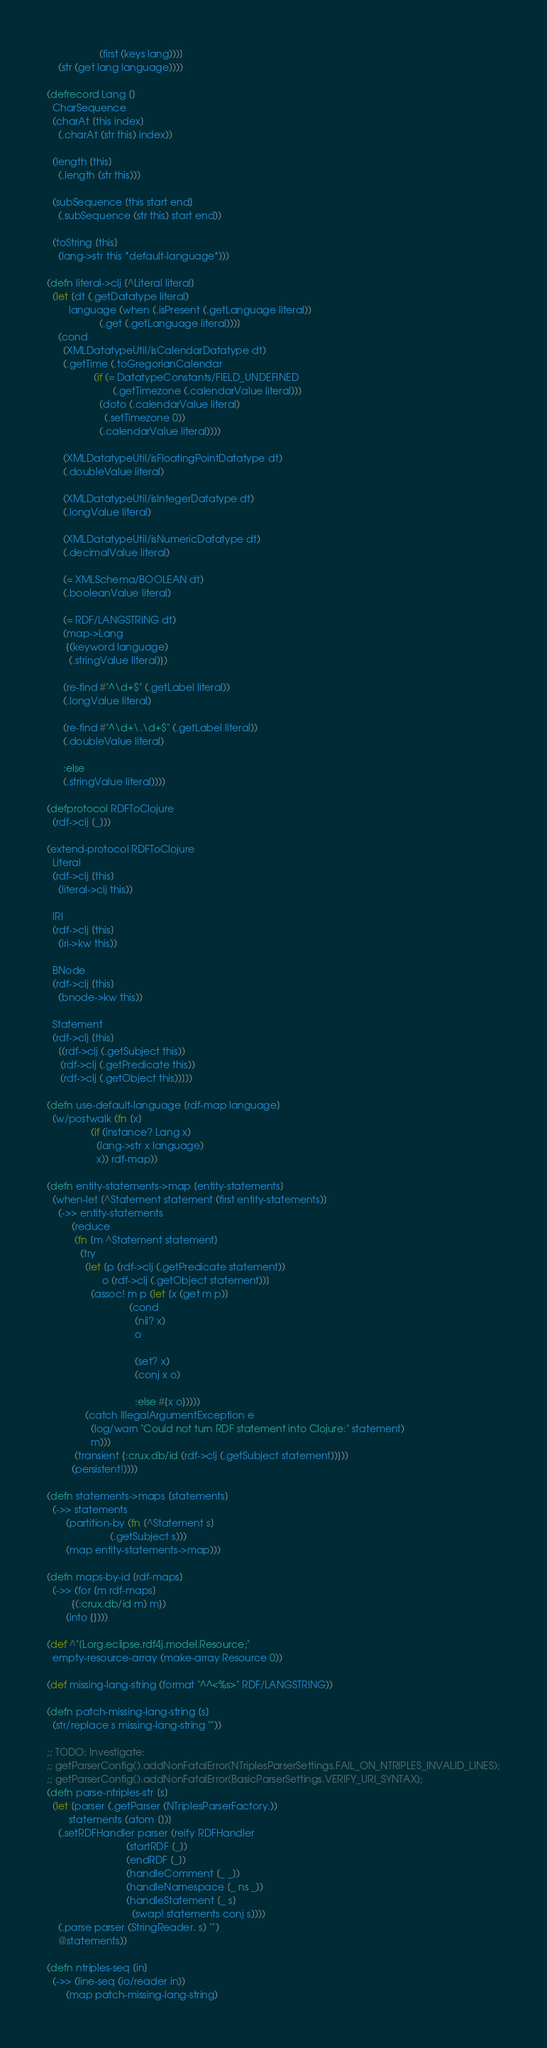<code> <loc_0><loc_0><loc_500><loc_500><_Clojure_>                   (first (keys lang)))]
    (str (get lang language))))

(defrecord Lang []
  CharSequence
  (charAt [this index]
    (.charAt (str this) index))

  (length [this]
    (.length (str this)))

  (subSequence [this start end]
    (.subSequence (str this) start end))

  (toString [this]
    (lang->str this *default-language*)))

(defn literal->clj [^Literal literal]
  (let [dt (.getDatatype literal)
        language (when (.isPresent (.getLanguage literal))
                   (.get (.getLanguage literal)))]
    (cond
      (XMLDatatypeUtil/isCalendarDatatype dt)
      (.getTime (.toGregorianCalendar
                 (if (= DatatypeConstants/FIELD_UNDEFINED
                        (.getTimezone (.calendarValue literal)))
                   (doto (.calendarValue literal)
                     (.setTimezone 0))
                   (.calendarValue literal))))

      (XMLDatatypeUtil/isFloatingPointDatatype dt)
      (.doubleValue literal)

      (XMLDatatypeUtil/isIntegerDatatype dt)
      (.longValue literal)

      (XMLDatatypeUtil/isNumericDatatype dt)
      (.decimalValue literal)

      (= XMLSchema/BOOLEAN dt)
      (.booleanValue literal)

      (= RDF/LANGSTRING dt)
      (map->Lang
       {(keyword language)
        (.stringValue literal)})

      (re-find #"^\d+$" (.getLabel literal))
      (.longValue literal)

      (re-find #"^\d+\.\d+$" (.getLabel literal))
      (.doubleValue literal)

      :else
      (.stringValue literal))))

(defprotocol RDFToClojure
  (rdf->clj [_]))

(extend-protocol RDFToClojure
  Literal
  (rdf->clj [this]
    (literal->clj this))

  IRI
  (rdf->clj [this]
    (iri->kw this))

  BNode
  (rdf->clj [this]
    (bnode->kw this))

  Statement
  (rdf->clj [this]
    [(rdf->clj (.getSubject this))
     (rdf->clj (.getPredicate this))
     (rdf->clj (.getObject this))]))

(defn use-default-language [rdf-map language]
  (w/postwalk (fn [x]
                (if (instance? Lang x)
                  (lang->str x language)
                  x)) rdf-map))

(defn entity-statements->map [entity-statements]
  (when-let [^Statement statement (first entity-statements)]
    (->> entity-statements
         (reduce
          (fn [m ^Statement statement]
            (try
              (let [p (rdf->clj (.getPredicate statement))
                    o (rdf->clj (.getObject statement))]
                (assoc! m p (let [x (get m p)]
                              (cond
                                (nil? x)
                                o

                                (set? x)
                                (conj x o)

                                :else #{x o}))))
              (catch IllegalArgumentException e
                (log/warn "Could not turn RDF statement into Clojure:" statement)
                m)))
          (transient {:crux.db/id (rdf->clj (.getSubject statement))}))
         (persistent!))))

(defn statements->maps [statements]
  (->> statements
       (partition-by (fn [^Statement s]
                       (.getSubject s)))
       (map entity-statements->map)))

(defn maps-by-id [rdf-maps]
  (->> (for [m rdf-maps]
         {(:crux.db/id m) m})
       (into {})))

(def ^"[Lorg.eclipse.rdf4j.model.Resource;"
  empty-resource-array (make-array Resource 0))

(def missing-lang-string (format "^^<%s>" RDF/LANGSTRING))

(defn patch-missing-lang-string [s]
  (str/replace s missing-lang-string ""))

;; TODO: Investigate:
;; getParserConfig().addNonFatalError(NTriplesParserSettings.FAIL_ON_NTRIPLES_INVALID_LINES);
;; getParserConfig().addNonFatalError(BasicParserSettings.VERIFY_URI_SYNTAX);
(defn parse-ntriples-str [s]
  (let [parser (.getParser (NTriplesParserFactory.))
        statements (atom [])]
    (.setRDFHandler parser (reify RDFHandler
                             (startRDF [_])
                             (endRDF [_])
                             (handleComment [_ _])
                             (handleNamespace [_ ns _])
                             (handleStatement [_ s]
                               (swap! statements conj s))))
    (.parse parser (StringReader. s) "")
    @statements))

(defn ntriples-seq [in]
  (->> (line-seq (io/reader in))
       (map patch-missing-lang-string)</code> 